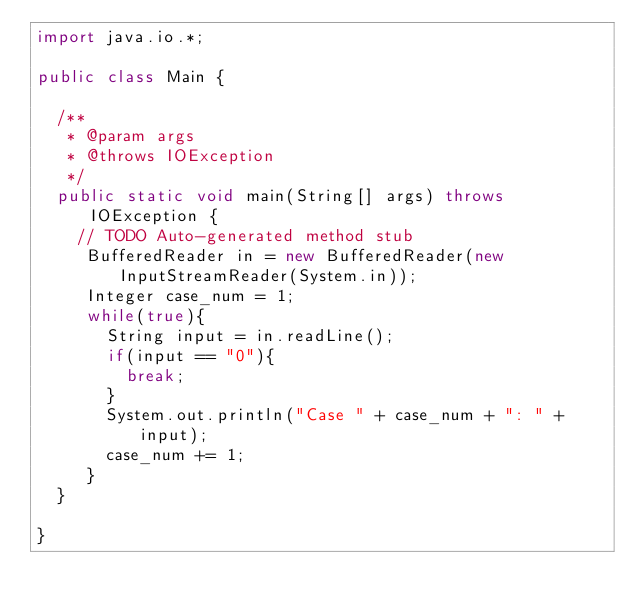<code> <loc_0><loc_0><loc_500><loc_500><_Java_>import java.io.*;

public class Main {

	/**
	 * @param args
	 * @throws IOException 
	 */
	public static void main(String[] args) throws IOException {
		// TODO Auto-generated method stub
		 BufferedReader in = new BufferedReader(new InputStreamReader(System.in));
		 Integer case_num = 1;
		 while(true){
			 String input = in.readLine();
			 if(input == "0"){
				 break;
			 }
			 System.out.println("Case " + case_num + ": " + input);
			 case_num += 1;
		 }
	}

}</code> 